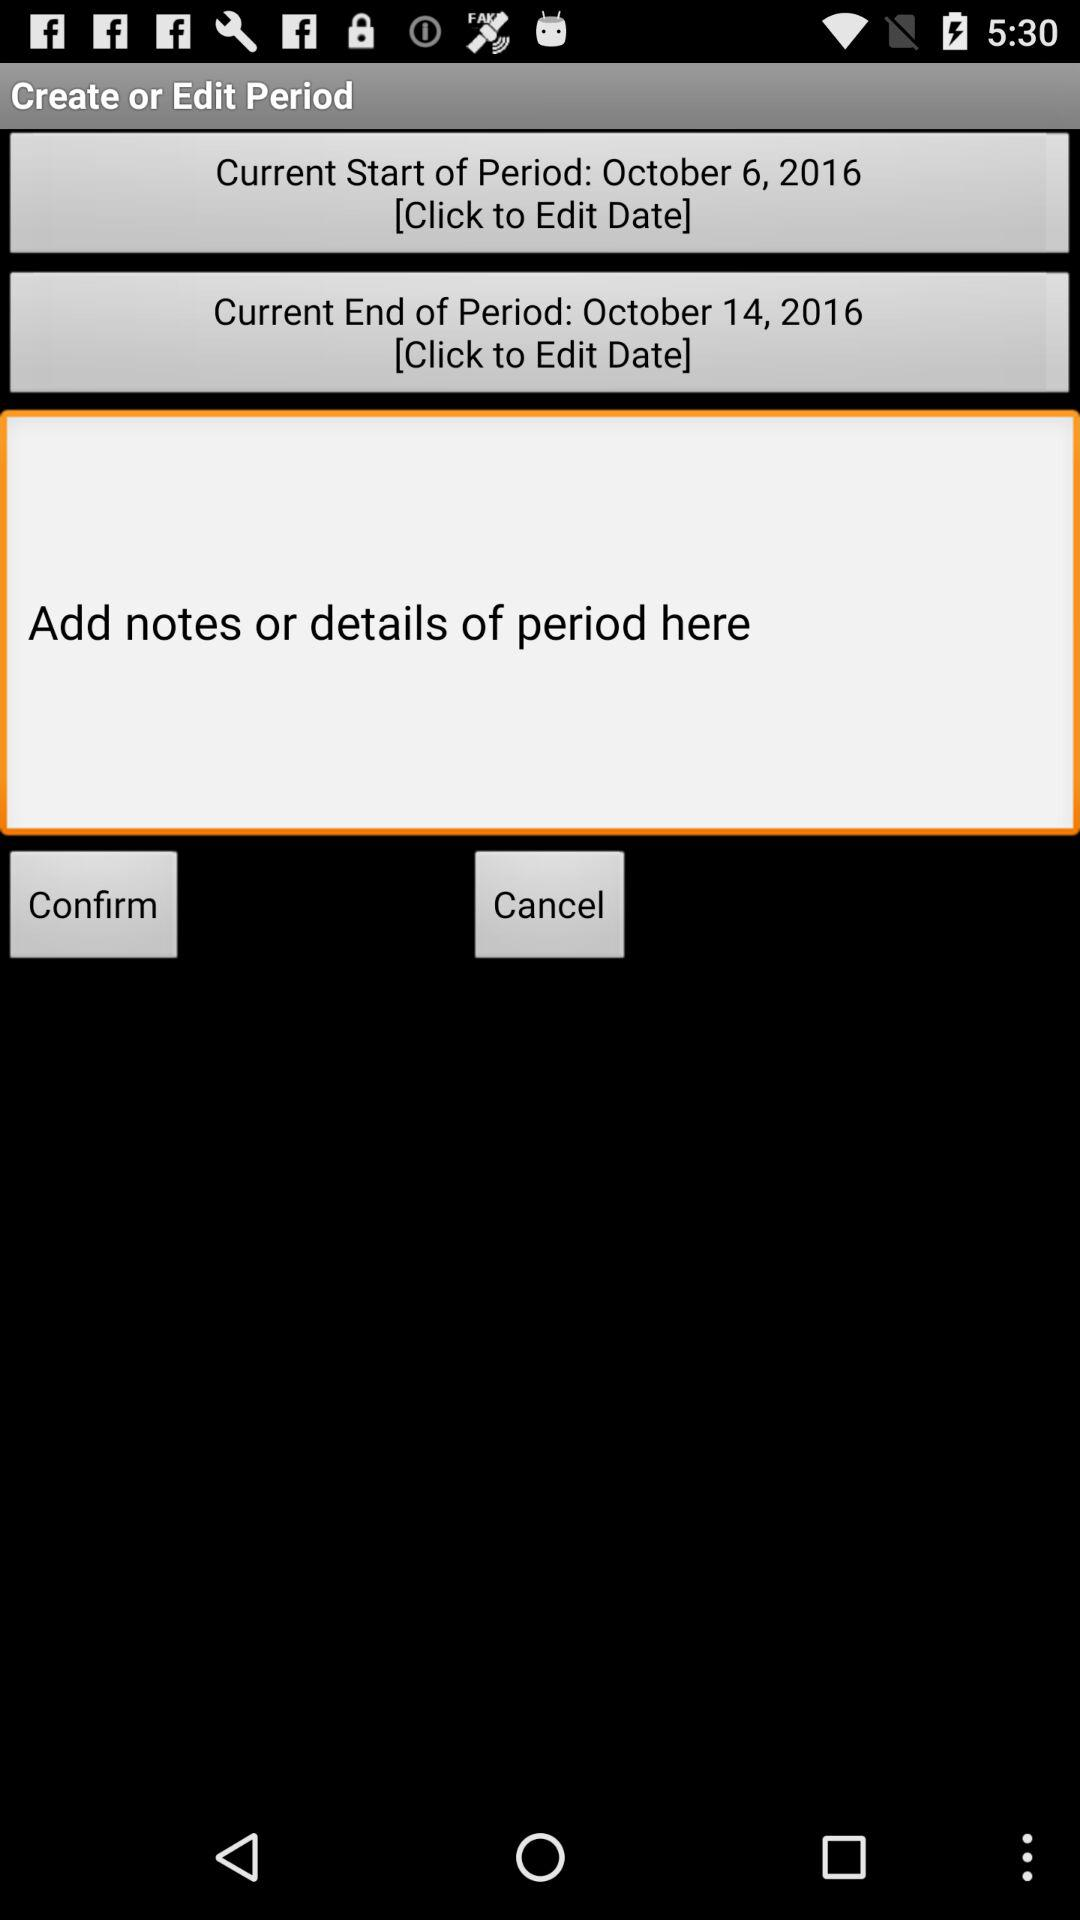What is the "Current Start of Period" date? The "Current Start of Period" date is October 6, 2016. 